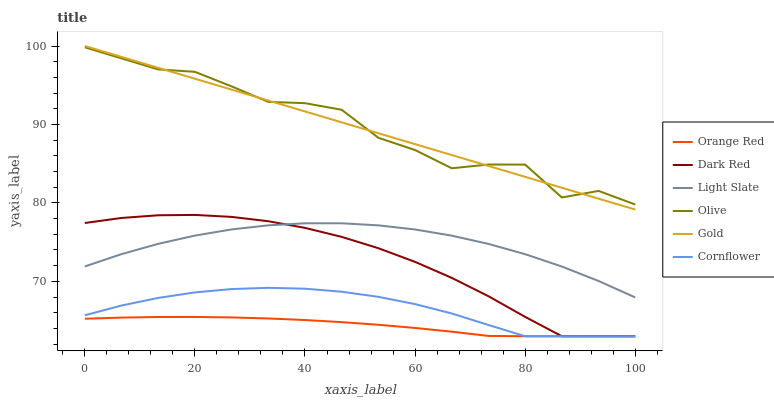Does Gold have the minimum area under the curve?
Answer yes or no. No. Does Gold have the maximum area under the curve?
Answer yes or no. No. Is Light Slate the smoothest?
Answer yes or no. No. Is Light Slate the roughest?
Answer yes or no. No. Does Gold have the lowest value?
Answer yes or no. No. Does Light Slate have the highest value?
Answer yes or no. No. Is Orange Red less than Gold?
Answer yes or no. Yes. Is Light Slate greater than Cornflower?
Answer yes or no. Yes. Does Orange Red intersect Gold?
Answer yes or no. No. 